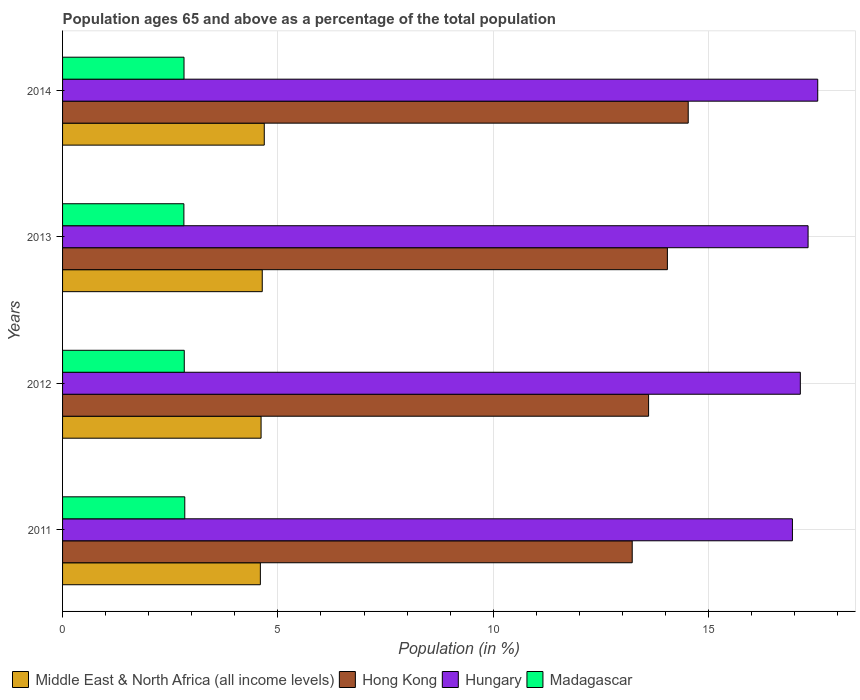How many different coloured bars are there?
Your answer should be very brief. 4. Are the number of bars per tick equal to the number of legend labels?
Your answer should be very brief. Yes. How many bars are there on the 4th tick from the bottom?
Your answer should be very brief. 4. What is the percentage of the population ages 65 and above in Hong Kong in 2013?
Offer a very short reply. 14.04. Across all years, what is the maximum percentage of the population ages 65 and above in Middle East & North Africa (all income levels)?
Provide a succinct answer. 4.68. Across all years, what is the minimum percentage of the population ages 65 and above in Hungary?
Offer a very short reply. 16.95. In which year was the percentage of the population ages 65 and above in Middle East & North Africa (all income levels) maximum?
Ensure brevity in your answer.  2014. In which year was the percentage of the population ages 65 and above in Madagascar minimum?
Give a very brief answer. 2013. What is the total percentage of the population ages 65 and above in Hungary in the graph?
Ensure brevity in your answer.  68.92. What is the difference between the percentage of the population ages 65 and above in Madagascar in 2011 and that in 2014?
Provide a short and direct response. 0.02. What is the difference between the percentage of the population ages 65 and above in Hungary in 2014 and the percentage of the population ages 65 and above in Madagascar in 2013?
Ensure brevity in your answer.  14.72. What is the average percentage of the population ages 65 and above in Hungary per year?
Your answer should be very brief. 17.23. In the year 2013, what is the difference between the percentage of the population ages 65 and above in Madagascar and percentage of the population ages 65 and above in Hungary?
Provide a succinct answer. -14.49. What is the ratio of the percentage of the population ages 65 and above in Madagascar in 2011 to that in 2014?
Make the answer very short. 1.01. Is the difference between the percentage of the population ages 65 and above in Madagascar in 2012 and 2014 greater than the difference between the percentage of the population ages 65 and above in Hungary in 2012 and 2014?
Keep it short and to the point. Yes. What is the difference between the highest and the second highest percentage of the population ages 65 and above in Hungary?
Offer a terse response. 0.22. What is the difference between the highest and the lowest percentage of the population ages 65 and above in Madagascar?
Your response must be concise. 0.02. In how many years, is the percentage of the population ages 65 and above in Hungary greater than the average percentage of the population ages 65 and above in Hungary taken over all years?
Provide a succinct answer. 2. Is the sum of the percentage of the population ages 65 and above in Middle East & North Africa (all income levels) in 2013 and 2014 greater than the maximum percentage of the population ages 65 and above in Hungary across all years?
Make the answer very short. No. What does the 3rd bar from the top in 2012 represents?
Provide a short and direct response. Hong Kong. What does the 2nd bar from the bottom in 2012 represents?
Provide a short and direct response. Hong Kong. Is it the case that in every year, the sum of the percentage of the population ages 65 and above in Hong Kong and percentage of the population ages 65 and above in Madagascar is greater than the percentage of the population ages 65 and above in Hungary?
Provide a succinct answer. No. How many bars are there?
Make the answer very short. 16. Are all the bars in the graph horizontal?
Your answer should be compact. Yes. Does the graph contain any zero values?
Offer a terse response. No. How many legend labels are there?
Your answer should be compact. 4. What is the title of the graph?
Give a very brief answer. Population ages 65 and above as a percentage of the total population. What is the label or title of the X-axis?
Your answer should be very brief. Population (in %). What is the label or title of the Y-axis?
Keep it short and to the point. Years. What is the Population (in %) in Middle East & North Africa (all income levels) in 2011?
Your answer should be compact. 4.59. What is the Population (in %) of Hong Kong in 2011?
Provide a short and direct response. 13.23. What is the Population (in %) in Hungary in 2011?
Offer a very short reply. 16.95. What is the Population (in %) in Madagascar in 2011?
Give a very brief answer. 2.84. What is the Population (in %) in Middle East & North Africa (all income levels) in 2012?
Make the answer very short. 4.61. What is the Population (in %) in Hong Kong in 2012?
Your answer should be very brief. 13.61. What is the Population (in %) of Hungary in 2012?
Ensure brevity in your answer.  17.13. What is the Population (in %) in Madagascar in 2012?
Offer a terse response. 2.83. What is the Population (in %) in Middle East & North Africa (all income levels) in 2013?
Your answer should be very brief. 4.64. What is the Population (in %) of Hong Kong in 2013?
Provide a short and direct response. 14.04. What is the Population (in %) of Hungary in 2013?
Provide a short and direct response. 17.31. What is the Population (in %) in Madagascar in 2013?
Provide a short and direct response. 2.82. What is the Population (in %) of Middle East & North Africa (all income levels) in 2014?
Your response must be concise. 4.68. What is the Population (in %) of Hong Kong in 2014?
Offer a very short reply. 14.53. What is the Population (in %) of Hungary in 2014?
Offer a very short reply. 17.53. What is the Population (in %) in Madagascar in 2014?
Ensure brevity in your answer.  2.82. Across all years, what is the maximum Population (in %) in Middle East & North Africa (all income levels)?
Provide a short and direct response. 4.68. Across all years, what is the maximum Population (in %) in Hong Kong?
Keep it short and to the point. 14.53. Across all years, what is the maximum Population (in %) of Hungary?
Your answer should be compact. 17.53. Across all years, what is the maximum Population (in %) in Madagascar?
Offer a very short reply. 2.84. Across all years, what is the minimum Population (in %) in Middle East & North Africa (all income levels)?
Ensure brevity in your answer.  4.59. Across all years, what is the minimum Population (in %) of Hong Kong?
Provide a succinct answer. 13.23. Across all years, what is the minimum Population (in %) of Hungary?
Make the answer very short. 16.95. Across all years, what is the minimum Population (in %) in Madagascar?
Offer a terse response. 2.82. What is the total Population (in %) in Middle East & North Africa (all income levels) in the graph?
Offer a terse response. 18.52. What is the total Population (in %) of Hong Kong in the graph?
Keep it short and to the point. 55.4. What is the total Population (in %) of Hungary in the graph?
Offer a very short reply. 68.92. What is the total Population (in %) of Madagascar in the graph?
Your response must be concise. 11.3. What is the difference between the Population (in %) of Middle East & North Africa (all income levels) in 2011 and that in 2012?
Ensure brevity in your answer.  -0.02. What is the difference between the Population (in %) of Hong Kong in 2011 and that in 2012?
Provide a short and direct response. -0.38. What is the difference between the Population (in %) in Hungary in 2011 and that in 2012?
Make the answer very short. -0.18. What is the difference between the Population (in %) in Madagascar in 2011 and that in 2012?
Your answer should be very brief. 0.01. What is the difference between the Population (in %) of Middle East & North Africa (all income levels) in 2011 and that in 2013?
Give a very brief answer. -0.04. What is the difference between the Population (in %) of Hong Kong in 2011 and that in 2013?
Provide a short and direct response. -0.82. What is the difference between the Population (in %) in Hungary in 2011 and that in 2013?
Make the answer very short. -0.36. What is the difference between the Population (in %) in Madagascar in 2011 and that in 2013?
Offer a very short reply. 0.02. What is the difference between the Population (in %) in Middle East & North Africa (all income levels) in 2011 and that in 2014?
Offer a very short reply. -0.09. What is the difference between the Population (in %) of Hong Kong in 2011 and that in 2014?
Keep it short and to the point. -1.3. What is the difference between the Population (in %) of Hungary in 2011 and that in 2014?
Your response must be concise. -0.59. What is the difference between the Population (in %) of Madagascar in 2011 and that in 2014?
Offer a very short reply. 0.02. What is the difference between the Population (in %) of Middle East & North Africa (all income levels) in 2012 and that in 2013?
Ensure brevity in your answer.  -0.03. What is the difference between the Population (in %) in Hong Kong in 2012 and that in 2013?
Make the answer very short. -0.44. What is the difference between the Population (in %) of Hungary in 2012 and that in 2013?
Offer a terse response. -0.18. What is the difference between the Population (in %) of Madagascar in 2012 and that in 2013?
Your answer should be compact. 0.01. What is the difference between the Population (in %) of Middle East & North Africa (all income levels) in 2012 and that in 2014?
Ensure brevity in your answer.  -0.07. What is the difference between the Population (in %) in Hong Kong in 2012 and that in 2014?
Make the answer very short. -0.92. What is the difference between the Population (in %) of Hungary in 2012 and that in 2014?
Ensure brevity in your answer.  -0.4. What is the difference between the Population (in %) of Madagascar in 2012 and that in 2014?
Your response must be concise. 0.01. What is the difference between the Population (in %) in Middle East & North Africa (all income levels) in 2013 and that in 2014?
Keep it short and to the point. -0.05. What is the difference between the Population (in %) of Hong Kong in 2013 and that in 2014?
Make the answer very short. -0.48. What is the difference between the Population (in %) of Hungary in 2013 and that in 2014?
Give a very brief answer. -0.22. What is the difference between the Population (in %) of Madagascar in 2013 and that in 2014?
Keep it short and to the point. -0. What is the difference between the Population (in %) in Middle East & North Africa (all income levels) in 2011 and the Population (in %) in Hong Kong in 2012?
Your response must be concise. -9.01. What is the difference between the Population (in %) in Middle East & North Africa (all income levels) in 2011 and the Population (in %) in Hungary in 2012?
Provide a short and direct response. -12.54. What is the difference between the Population (in %) in Middle East & North Africa (all income levels) in 2011 and the Population (in %) in Madagascar in 2012?
Offer a very short reply. 1.77. What is the difference between the Population (in %) of Hong Kong in 2011 and the Population (in %) of Hungary in 2012?
Provide a succinct answer. -3.9. What is the difference between the Population (in %) in Hong Kong in 2011 and the Population (in %) in Madagascar in 2012?
Give a very brief answer. 10.4. What is the difference between the Population (in %) in Hungary in 2011 and the Population (in %) in Madagascar in 2012?
Ensure brevity in your answer.  14.12. What is the difference between the Population (in %) of Middle East & North Africa (all income levels) in 2011 and the Population (in %) of Hong Kong in 2013?
Keep it short and to the point. -9.45. What is the difference between the Population (in %) in Middle East & North Africa (all income levels) in 2011 and the Population (in %) in Hungary in 2013?
Offer a very short reply. -12.72. What is the difference between the Population (in %) of Middle East & North Africa (all income levels) in 2011 and the Population (in %) of Madagascar in 2013?
Ensure brevity in your answer.  1.78. What is the difference between the Population (in %) of Hong Kong in 2011 and the Population (in %) of Hungary in 2013?
Offer a terse response. -4.08. What is the difference between the Population (in %) of Hong Kong in 2011 and the Population (in %) of Madagascar in 2013?
Keep it short and to the point. 10.41. What is the difference between the Population (in %) in Hungary in 2011 and the Population (in %) in Madagascar in 2013?
Keep it short and to the point. 14.13. What is the difference between the Population (in %) in Middle East & North Africa (all income levels) in 2011 and the Population (in %) in Hong Kong in 2014?
Your answer should be very brief. -9.93. What is the difference between the Population (in %) in Middle East & North Africa (all income levels) in 2011 and the Population (in %) in Hungary in 2014?
Your response must be concise. -12.94. What is the difference between the Population (in %) of Middle East & North Africa (all income levels) in 2011 and the Population (in %) of Madagascar in 2014?
Provide a short and direct response. 1.77. What is the difference between the Population (in %) in Hong Kong in 2011 and the Population (in %) in Hungary in 2014?
Offer a terse response. -4.31. What is the difference between the Population (in %) of Hong Kong in 2011 and the Population (in %) of Madagascar in 2014?
Ensure brevity in your answer.  10.41. What is the difference between the Population (in %) of Hungary in 2011 and the Population (in %) of Madagascar in 2014?
Your response must be concise. 14.13. What is the difference between the Population (in %) of Middle East & North Africa (all income levels) in 2012 and the Population (in %) of Hong Kong in 2013?
Provide a succinct answer. -9.43. What is the difference between the Population (in %) in Middle East & North Africa (all income levels) in 2012 and the Population (in %) in Hungary in 2013?
Make the answer very short. -12.7. What is the difference between the Population (in %) of Middle East & North Africa (all income levels) in 2012 and the Population (in %) of Madagascar in 2013?
Your answer should be compact. 1.79. What is the difference between the Population (in %) in Hong Kong in 2012 and the Population (in %) in Hungary in 2013?
Provide a succinct answer. -3.7. What is the difference between the Population (in %) in Hong Kong in 2012 and the Population (in %) in Madagascar in 2013?
Keep it short and to the point. 10.79. What is the difference between the Population (in %) of Hungary in 2012 and the Population (in %) of Madagascar in 2013?
Offer a terse response. 14.31. What is the difference between the Population (in %) in Middle East & North Africa (all income levels) in 2012 and the Population (in %) in Hong Kong in 2014?
Your response must be concise. -9.92. What is the difference between the Population (in %) of Middle East & North Africa (all income levels) in 2012 and the Population (in %) of Hungary in 2014?
Keep it short and to the point. -12.92. What is the difference between the Population (in %) of Middle East & North Africa (all income levels) in 2012 and the Population (in %) of Madagascar in 2014?
Give a very brief answer. 1.79. What is the difference between the Population (in %) of Hong Kong in 2012 and the Population (in %) of Hungary in 2014?
Your answer should be compact. -3.93. What is the difference between the Population (in %) of Hong Kong in 2012 and the Population (in %) of Madagascar in 2014?
Offer a very short reply. 10.79. What is the difference between the Population (in %) of Hungary in 2012 and the Population (in %) of Madagascar in 2014?
Offer a terse response. 14.31. What is the difference between the Population (in %) in Middle East & North Africa (all income levels) in 2013 and the Population (in %) in Hong Kong in 2014?
Keep it short and to the point. -9.89. What is the difference between the Population (in %) of Middle East & North Africa (all income levels) in 2013 and the Population (in %) of Hungary in 2014?
Give a very brief answer. -12.9. What is the difference between the Population (in %) in Middle East & North Africa (all income levels) in 2013 and the Population (in %) in Madagascar in 2014?
Offer a terse response. 1.82. What is the difference between the Population (in %) in Hong Kong in 2013 and the Population (in %) in Hungary in 2014?
Your answer should be very brief. -3.49. What is the difference between the Population (in %) of Hong Kong in 2013 and the Population (in %) of Madagascar in 2014?
Your answer should be very brief. 11.22. What is the difference between the Population (in %) of Hungary in 2013 and the Population (in %) of Madagascar in 2014?
Your response must be concise. 14.49. What is the average Population (in %) in Middle East & North Africa (all income levels) per year?
Keep it short and to the point. 4.63. What is the average Population (in %) of Hong Kong per year?
Offer a very short reply. 13.85. What is the average Population (in %) in Hungary per year?
Ensure brevity in your answer.  17.23. What is the average Population (in %) of Madagascar per year?
Your response must be concise. 2.83. In the year 2011, what is the difference between the Population (in %) in Middle East & North Africa (all income levels) and Population (in %) in Hong Kong?
Give a very brief answer. -8.63. In the year 2011, what is the difference between the Population (in %) in Middle East & North Africa (all income levels) and Population (in %) in Hungary?
Your answer should be very brief. -12.35. In the year 2011, what is the difference between the Population (in %) of Middle East & North Africa (all income levels) and Population (in %) of Madagascar?
Ensure brevity in your answer.  1.75. In the year 2011, what is the difference between the Population (in %) in Hong Kong and Population (in %) in Hungary?
Offer a terse response. -3.72. In the year 2011, what is the difference between the Population (in %) in Hong Kong and Population (in %) in Madagascar?
Your answer should be compact. 10.39. In the year 2011, what is the difference between the Population (in %) in Hungary and Population (in %) in Madagascar?
Provide a short and direct response. 14.11. In the year 2012, what is the difference between the Population (in %) in Middle East & North Africa (all income levels) and Population (in %) in Hong Kong?
Provide a short and direct response. -9. In the year 2012, what is the difference between the Population (in %) in Middle East & North Africa (all income levels) and Population (in %) in Hungary?
Provide a short and direct response. -12.52. In the year 2012, what is the difference between the Population (in %) in Middle East & North Africa (all income levels) and Population (in %) in Madagascar?
Your response must be concise. 1.78. In the year 2012, what is the difference between the Population (in %) in Hong Kong and Population (in %) in Hungary?
Your answer should be very brief. -3.52. In the year 2012, what is the difference between the Population (in %) of Hong Kong and Population (in %) of Madagascar?
Ensure brevity in your answer.  10.78. In the year 2012, what is the difference between the Population (in %) of Hungary and Population (in %) of Madagascar?
Your answer should be very brief. 14.3. In the year 2013, what is the difference between the Population (in %) of Middle East & North Africa (all income levels) and Population (in %) of Hong Kong?
Your answer should be compact. -9.41. In the year 2013, what is the difference between the Population (in %) in Middle East & North Africa (all income levels) and Population (in %) in Hungary?
Provide a short and direct response. -12.67. In the year 2013, what is the difference between the Population (in %) of Middle East & North Africa (all income levels) and Population (in %) of Madagascar?
Your response must be concise. 1.82. In the year 2013, what is the difference between the Population (in %) of Hong Kong and Population (in %) of Hungary?
Provide a succinct answer. -3.27. In the year 2013, what is the difference between the Population (in %) of Hong Kong and Population (in %) of Madagascar?
Ensure brevity in your answer.  11.23. In the year 2013, what is the difference between the Population (in %) in Hungary and Population (in %) in Madagascar?
Give a very brief answer. 14.49. In the year 2014, what is the difference between the Population (in %) of Middle East & North Africa (all income levels) and Population (in %) of Hong Kong?
Make the answer very short. -9.84. In the year 2014, what is the difference between the Population (in %) of Middle East & North Africa (all income levels) and Population (in %) of Hungary?
Offer a very short reply. -12.85. In the year 2014, what is the difference between the Population (in %) of Middle East & North Africa (all income levels) and Population (in %) of Madagascar?
Your answer should be very brief. 1.86. In the year 2014, what is the difference between the Population (in %) in Hong Kong and Population (in %) in Hungary?
Ensure brevity in your answer.  -3.01. In the year 2014, what is the difference between the Population (in %) of Hong Kong and Population (in %) of Madagascar?
Ensure brevity in your answer.  11.71. In the year 2014, what is the difference between the Population (in %) in Hungary and Population (in %) in Madagascar?
Provide a short and direct response. 14.71. What is the ratio of the Population (in %) in Middle East & North Africa (all income levels) in 2011 to that in 2012?
Your answer should be compact. 1. What is the ratio of the Population (in %) of Hong Kong in 2011 to that in 2012?
Your response must be concise. 0.97. What is the ratio of the Population (in %) in Hungary in 2011 to that in 2012?
Provide a short and direct response. 0.99. What is the ratio of the Population (in %) in Madagascar in 2011 to that in 2012?
Your response must be concise. 1. What is the ratio of the Population (in %) in Middle East & North Africa (all income levels) in 2011 to that in 2013?
Give a very brief answer. 0.99. What is the ratio of the Population (in %) of Hong Kong in 2011 to that in 2013?
Offer a terse response. 0.94. What is the ratio of the Population (in %) of Madagascar in 2011 to that in 2013?
Offer a very short reply. 1.01. What is the ratio of the Population (in %) in Middle East & North Africa (all income levels) in 2011 to that in 2014?
Provide a short and direct response. 0.98. What is the ratio of the Population (in %) of Hong Kong in 2011 to that in 2014?
Your answer should be very brief. 0.91. What is the ratio of the Population (in %) of Hungary in 2011 to that in 2014?
Give a very brief answer. 0.97. What is the ratio of the Population (in %) in Madagascar in 2011 to that in 2014?
Your response must be concise. 1.01. What is the ratio of the Population (in %) of Middle East & North Africa (all income levels) in 2012 to that in 2013?
Offer a terse response. 0.99. What is the ratio of the Population (in %) of Hong Kong in 2012 to that in 2013?
Give a very brief answer. 0.97. What is the ratio of the Population (in %) of Madagascar in 2012 to that in 2013?
Your answer should be very brief. 1. What is the ratio of the Population (in %) of Middle East & North Africa (all income levels) in 2012 to that in 2014?
Offer a terse response. 0.98. What is the ratio of the Population (in %) in Hong Kong in 2012 to that in 2014?
Provide a succinct answer. 0.94. What is the ratio of the Population (in %) in Hungary in 2012 to that in 2014?
Provide a succinct answer. 0.98. What is the ratio of the Population (in %) of Madagascar in 2012 to that in 2014?
Your answer should be very brief. 1. What is the ratio of the Population (in %) in Middle East & North Africa (all income levels) in 2013 to that in 2014?
Provide a succinct answer. 0.99. What is the ratio of the Population (in %) of Hong Kong in 2013 to that in 2014?
Make the answer very short. 0.97. What is the ratio of the Population (in %) in Hungary in 2013 to that in 2014?
Keep it short and to the point. 0.99. What is the difference between the highest and the second highest Population (in %) of Middle East & North Africa (all income levels)?
Make the answer very short. 0.05. What is the difference between the highest and the second highest Population (in %) of Hong Kong?
Keep it short and to the point. 0.48. What is the difference between the highest and the second highest Population (in %) in Hungary?
Make the answer very short. 0.22. What is the difference between the highest and the second highest Population (in %) in Madagascar?
Your answer should be compact. 0.01. What is the difference between the highest and the lowest Population (in %) in Middle East & North Africa (all income levels)?
Your answer should be compact. 0.09. What is the difference between the highest and the lowest Population (in %) in Hong Kong?
Ensure brevity in your answer.  1.3. What is the difference between the highest and the lowest Population (in %) in Hungary?
Your answer should be compact. 0.59. What is the difference between the highest and the lowest Population (in %) of Madagascar?
Ensure brevity in your answer.  0.02. 